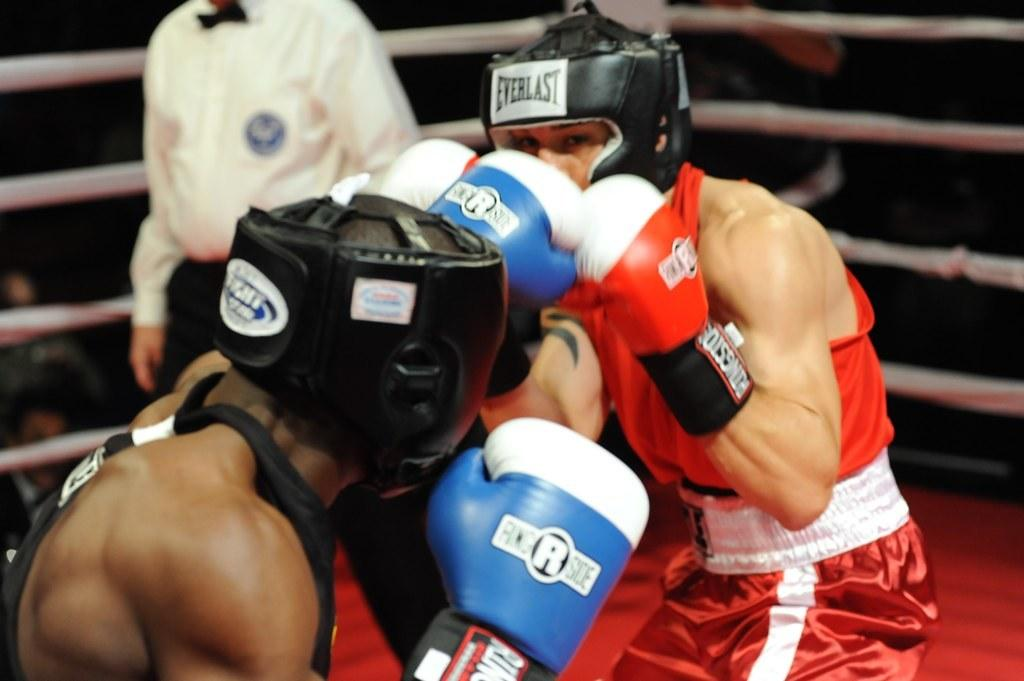How many people are in the image? There are two persons in the center of the image. What are the two persons wearing? The two persons are wearing gloves. What are the two persons doing in the image? The two persons are fighting. Can you describe the background of the image? There is another person and some objects in the background of the image. What type of ghost can be seen in the image? There is no ghost present in the image. What trick are the two persons performing in the image? The two persons are fighting, not performing a trick. 